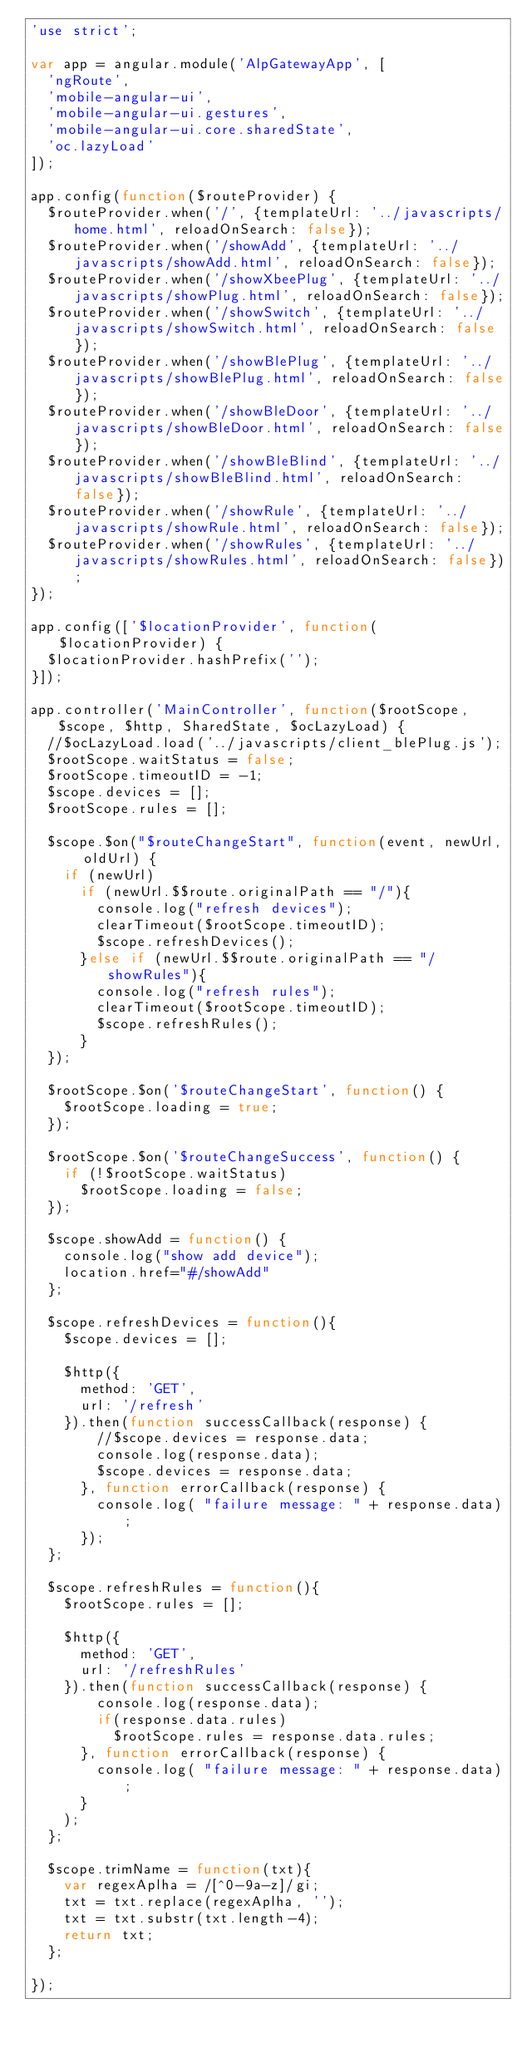Convert code to text. <code><loc_0><loc_0><loc_500><loc_500><_JavaScript_>'use strict';

var app = angular.module('AlpGatewayApp', [
  'ngRoute',
  'mobile-angular-ui',
  'mobile-angular-ui.gestures',
  'mobile-angular-ui.core.sharedState',
  'oc.lazyLoad'
]);

app.config(function($routeProvider) {
  $routeProvider.when('/', {templateUrl: '../javascripts/home.html', reloadOnSearch: false});
  $routeProvider.when('/showAdd', {templateUrl: '../javascripts/showAdd.html', reloadOnSearch: false});
  $routeProvider.when('/showXbeePlug', {templateUrl: '../javascripts/showPlug.html', reloadOnSearch: false});
  $routeProvider.when('/showSwitch', {templateUrl: '../javascripts/showSwitch.html', reloadOnSearch: false});
  $routeProvider.when('/showBlePlug', {templateUrl: '../javascripts/showBlePlug.html', reloadOnSearch: false});
  $routeProvider.when('/showBleDoor', {templateUrl: '../javascripts/showBleDoor.html', reloadOnSearch: false});
  $routeProvider.when('/showBleBlind', {templateUrl: '../javascripts/showBleBlind.html', reloadOnSearch: false});
  $routeProvider.when('/showRule', {templateUrl: '../javascripts/showRule.html', reloadOnSearch: false});
  $routeProvider.when('/showRules', {templateUrl: '../javascripts/showRules.html', reloadOnSearch: false});
});

app.config(['$locationProvider', function($locationProvider) {
  $locationProvider.hashPrefix('');
}]);

app.controller('MainController', function($rootScope, $scope, $http, SharedState, $ocLazyLoad) {
  //$ocLazyLoad.load('../javascripts/client_blePlug.js');
  $rootScope.waitStatus = false;
  $rootScope.timeoutID = -1;
  $scope.devices = [];
  $rootScope.rules = [];

  $scope.$on("$routeChangeStart", function(event, newUrl, oldUrl) {
    if (newUrl)
      if (newUrl.$$route.originalPath == "/"){
        console.log("refresh devices");
        clearTimeout($rootScope.timeoutID);
        $scope.refreshDevices();
      }else if (newUrl.$$route.originalPath == "/showRules"){
        console.log("refresh rules");
        clearTimeout($rootScope.timeoutID);
        $scope.refreshRules();        
      }
  });

  $rootScope.$on('$routeChangeStart', function() {
    $rootScope.loading = true;
  });

  $rootScope.$on('$routeChangeSuccess', function() {
    if (!$rootScope.waitStatus)
      $rootScope.loading = false;
  });

  $scope.showAdd = function() {
  	console.log("show add device");
  	location.href="#/showAdd"
  };

  $scope.refreshDevices = function(){
    $scope.devices = [];

    $http({
      method: 'GET',
      url: '/refresh'
    }).then(function successCallback(response) {
        //$scope.devices = response.data;
        console.log(response.data);
        $scope.devices = response.data;
      }, function errorCallback(response) {
        console.log( "failure message: " + response.data);
      });
  };

  $scope.refreshRules = function(){
    $rootScope.rules = [];

    $http({
      method: 'GET',
      url: '/refreshRules'
    }).then(function successCallback(response) {
        console.log(response.data);
        if(response.data.rules)
          $rootScope.rules = response.data.rules;
      }, function errorCallback(response) {
        console.log( "failure message: " + response.data);
      }
    );
  };

  $scope.trimName = function(txt){
    var regexAplha = /[^0-9a-z]/gi;
    txt = txt.replace(regexAplha, '');
    txt = txt.substr(txt.length-4);
    return txt;
  };

});

</code> 